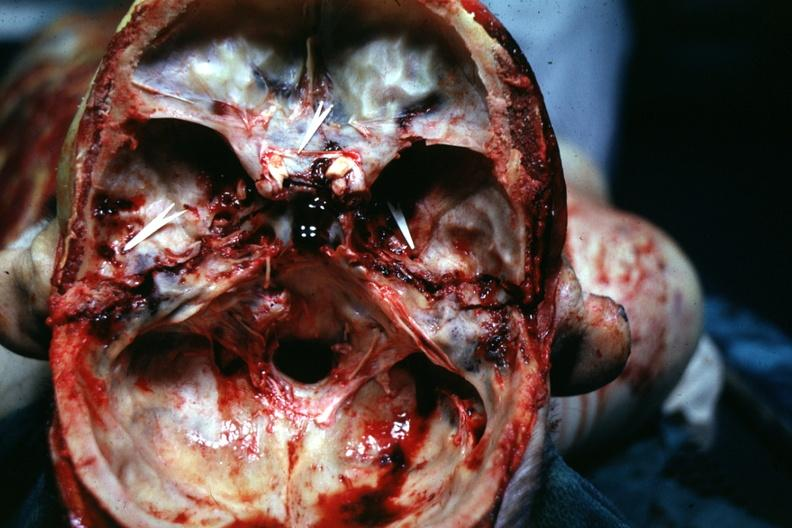s basilar skull fracture present?
Answer the question using a single word or phrase. Yes 